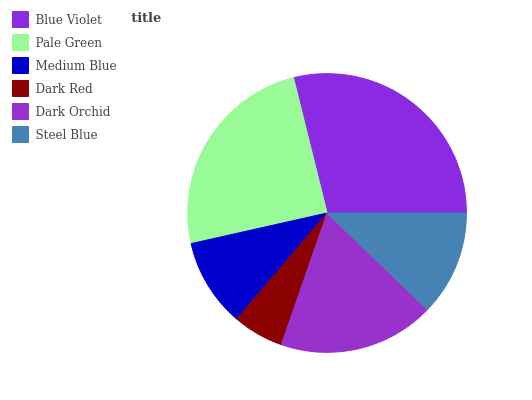Is Dark Red the minimum?
Answer yes or no. Yes. Is Blue Violet the maximum?
Answer yes or no. Yes. Is Pale Green the minimum?
Answer yes or no. No. Is Pale Green the maximum?
Answer yes or no. No. Is Blue Violet greater than Pale Green?
Answer yes or no. Yes. Is Pale Green less than Blue Violet?
Answer yes or no. Yes. Is Pale Green greater than Blue Violet?
Answer yes or no. No. Is Blue Violet less than Pale Green?
Answer yes or no. No. Is Dark Orchid the high median?
Answer yes or no. Yes. Is Steel Blue the low median?
Answer yes or no. Yes. Is Medium Blue the high median?
Answer yes or no. No. Is Dark Red the low median?
Answer yes or no. No. 